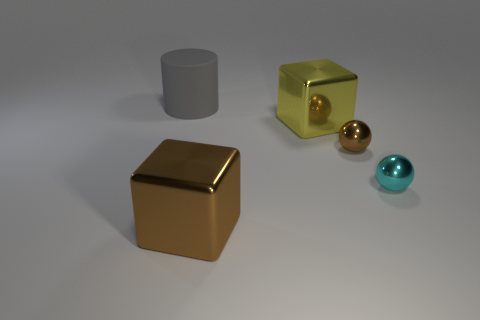Are there any other things that have the same size as the brown ball?
Keep it short and to the point. Yes. Is the number of brown blocks to the left of the rubber cylinder less than the number of small metallic things that are in front of the big brown thing?
Offer a terse response. No. Is there any other thing that has the same shape as the large yellow shiny object?
Give a very brief answer. Yes. How many big shiny cubes are on the left side of the metallic block to the left of the large object that is right of the big brown cube?
Ensure brevity in your answer.  0. How many large cylinders are behind the large cylinder?
Offer a very short reply. 0. How many balls have the same material as the cylinder?
Offer a terse response. 0. There is another block that is made of the same material as the large brown block; what is its color?
Keep it short and to the point. Yellow. The large object right of the large metallic object in front of the large block behind the big brown shiny block is made of what material?
Your response must be concise. Metal. There is a metal block that is on the left side of the yellow shiny block; is it the same size as the large rubber cylinder?
Your response must be concise. Yes. How many tiny objects are either brown metal blocks or yellow metallic blocks?
Your response must be concise. 0. 